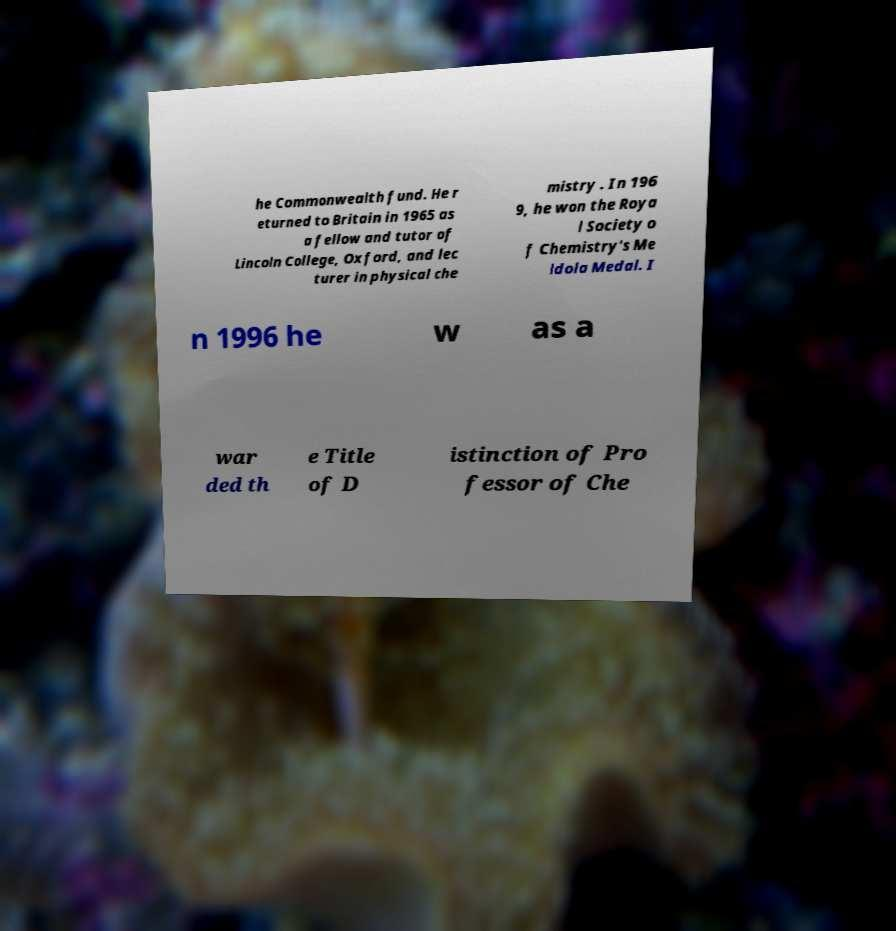What messages or text are displayed in this image? I need them in a readable, typed format. he Commonwealth fund. He r eturned to Britain in 1965 as a fellow and tutor of Lincoln College, Oxford, and lec turer in physical che mistry . In 196 9, he won the Roya l Society o f Chemistry's Me ldola Medal. I n 1996 he w as a war ded th e Title of D istinction of Pro fessor of Che 